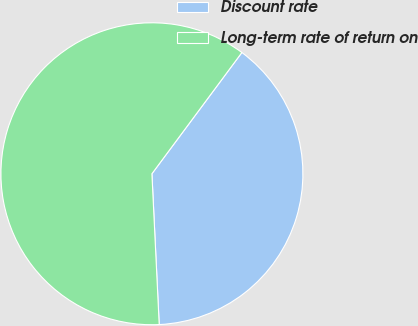Convert chart. <chart><loc_0><loc_0><loc_500><loc_500><pie_chart><fcel>Discount rate<fcel>Long-term rate of return on<nl><fcel>39.07%<fcel>60.93%<nl></chart> 